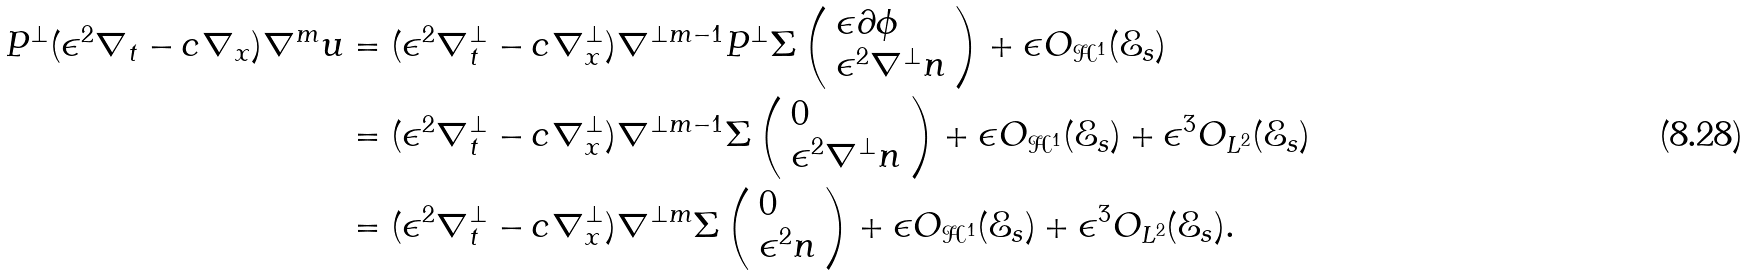<formula> <loc_0><loc_0><loc_500><loc_500>P ^ { \perp } ( \epsilon ^ { 2 } \nabla _ { t } - c \nabla _ { x } ) \nabla ^ { m } u & = ( \epsilon ^ { 2 } \nabla ^ { \perp } _ { t } - c \nabla ^ { \perp } _ { x } ) \nabla ^ { \perp m - 1 } P ^ { \perp } \Sigma \left ( \begin{array} { l } \epsilon \partial \phi \\ \epsilon ^ { 2 } \nabla ^ { \perp } n \end{array} \right ) + \epsilon O _ { \mathcal { H } ^ { 1 } } ( \mathcal { E } _ { s } ) \\ & = ( \epsilon ^ { 2 } \nabla ^ { \perp } _ { t } - c \nabla ^ { \perp } _ { x } ) \nabla ^ { \perp m - 1 } \Sigma \left ( \begin{array} { l } 0 \\ \epsilon ^ { 2 } \nabla ^ { \perp } n \end{array} \right ) + \epsilon O _ { \mathcal { H } ^ { 1 } } ( \mathcal { E } _ { s } ) + \epsilon ^ { 3 } O _ { L ^ { 2 } } ( \mathcal { E } _ { s } ) \\ & = ( \epsilon ^ { 2 } \nabla ^ { \perp } _ { t } - c \nabla ^ { \perp } _ { x } ) \nabla ^ { \perp m } \Sigma \left ( \begin{array} { l } 0 \\ \epsilon ^ { 2 } n \end{array} \right ) + \epsilon O _ { \mathcal { H } ^ { 1 } } ( \mathcal { E } _ { s } ) + \epsilon ^ { 3 } O _ { L ^ { 2 } } ( \mathcal { E } _ { s } ) .</formula> 